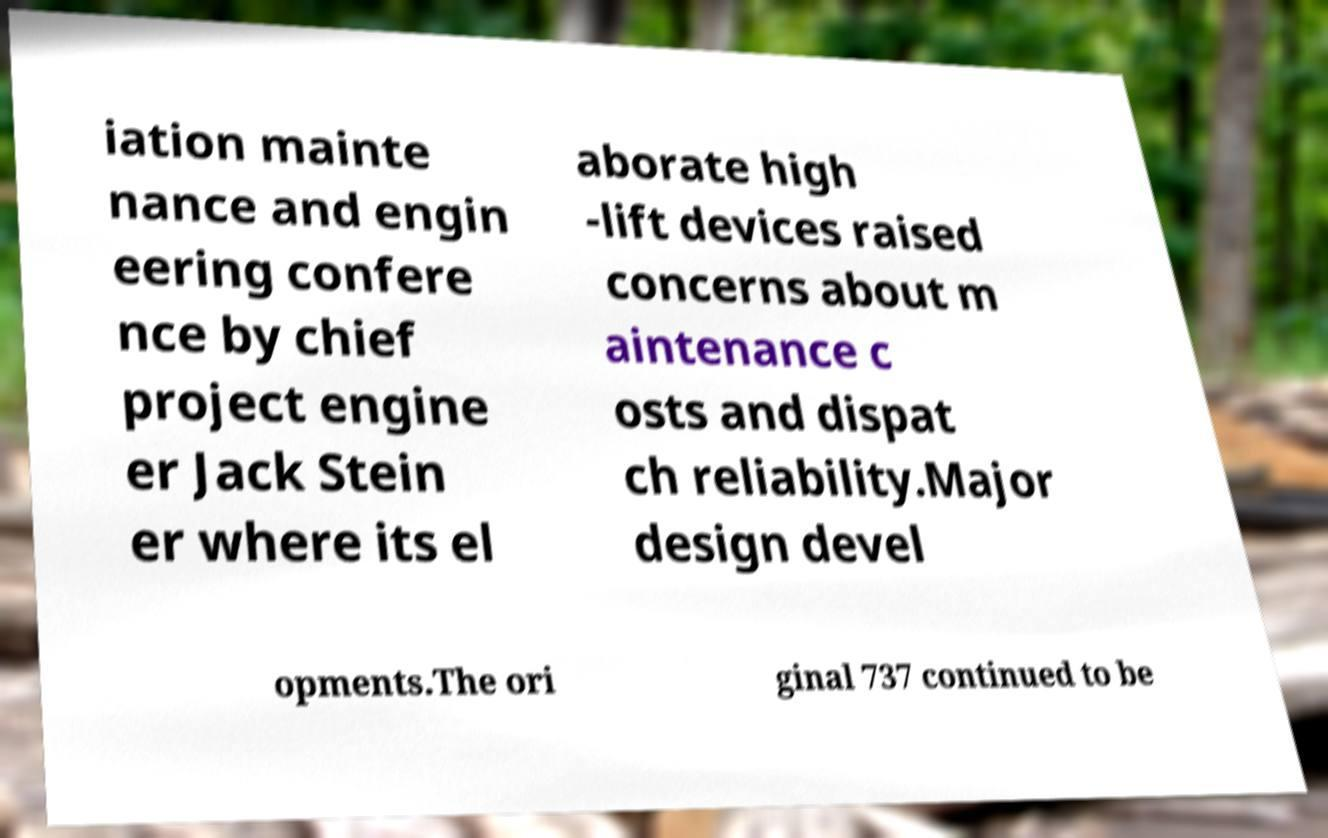Can you accurately transcribe the text from the provided image for me? iation mainte nance and engin eering confere nce by chief project engine er Jack Stein er where its el aborate high -lift devices raised concerns about m aintenance c osts and dispat ch reliability.Major design devel opments.The ori ginal 737 continued to be 